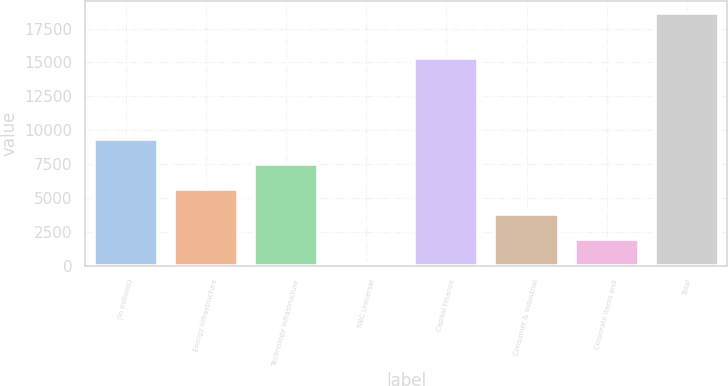Convert chart to OTSL. <chart><loc_0><loc_0><loc_500><loc_500><bar_chart><fcel>(In millions)<fcel>Energy Infrastructure<fcel>Technology Infrastructure<fcel>NBC Universal<fcel>Capital Finance<fcel>Consumer & Industrial<fcel>Corporate items and<fcel>Total<nl><fcel>9380.5<fcel>5680.7<fcel>7530.6<fcel>131<fcel>15313<fcel>3830.8<fcel>1980.9<fcel>18630<nl></chart> 